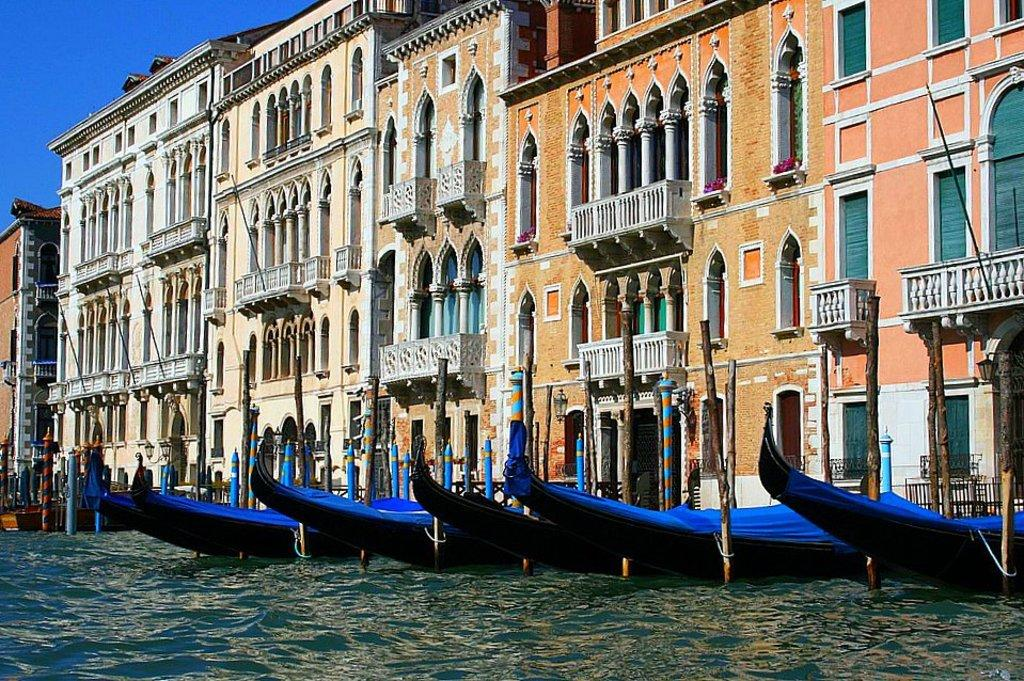What type of structures can be seen in the image? There are buildings in the image. What is located in the foreground of the image? There are boats in the water in the foreground of the image. What type of objects are present in the image besides the buildings and boats? There are wooden poles in the image. What is visible at the top of the image? The sky is visible at the top of the image. What is present at the bottom of the image? Water is present at the bottom of the image. Can you tell me how many wrens are perched on the wooden poles in the image? There are no wrens present in the image; it only features buildings, boats, wooden poles, sky, and water. What color is the bead that is hanging from the wooden poles in the image? There are no beads hanging from the wooden poles in the image. 